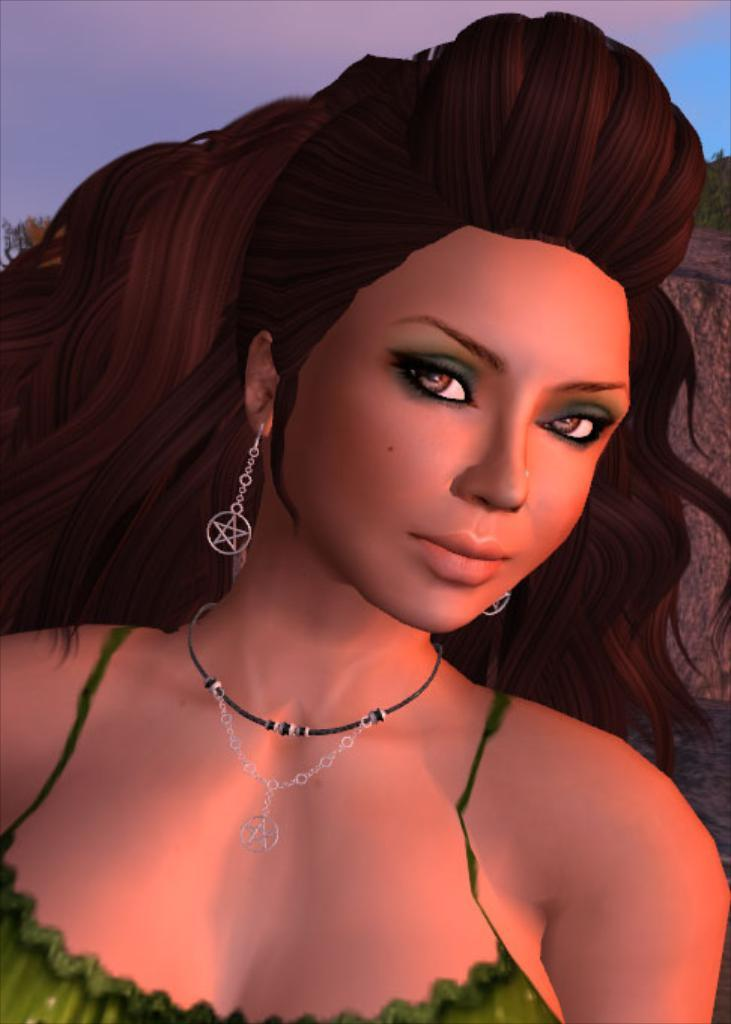What is the main subject of the animated picture? The main subject of the animated picture is a woman. What can be seen in the background of the image? There are trees, a rock, and the sky visible in the background. What type of smile can be seen on the woman's thumb in the image? There is no thumb or smile present on the woman in the image, as it is an animated picture of a woman without any visible hands or facial expressions. 